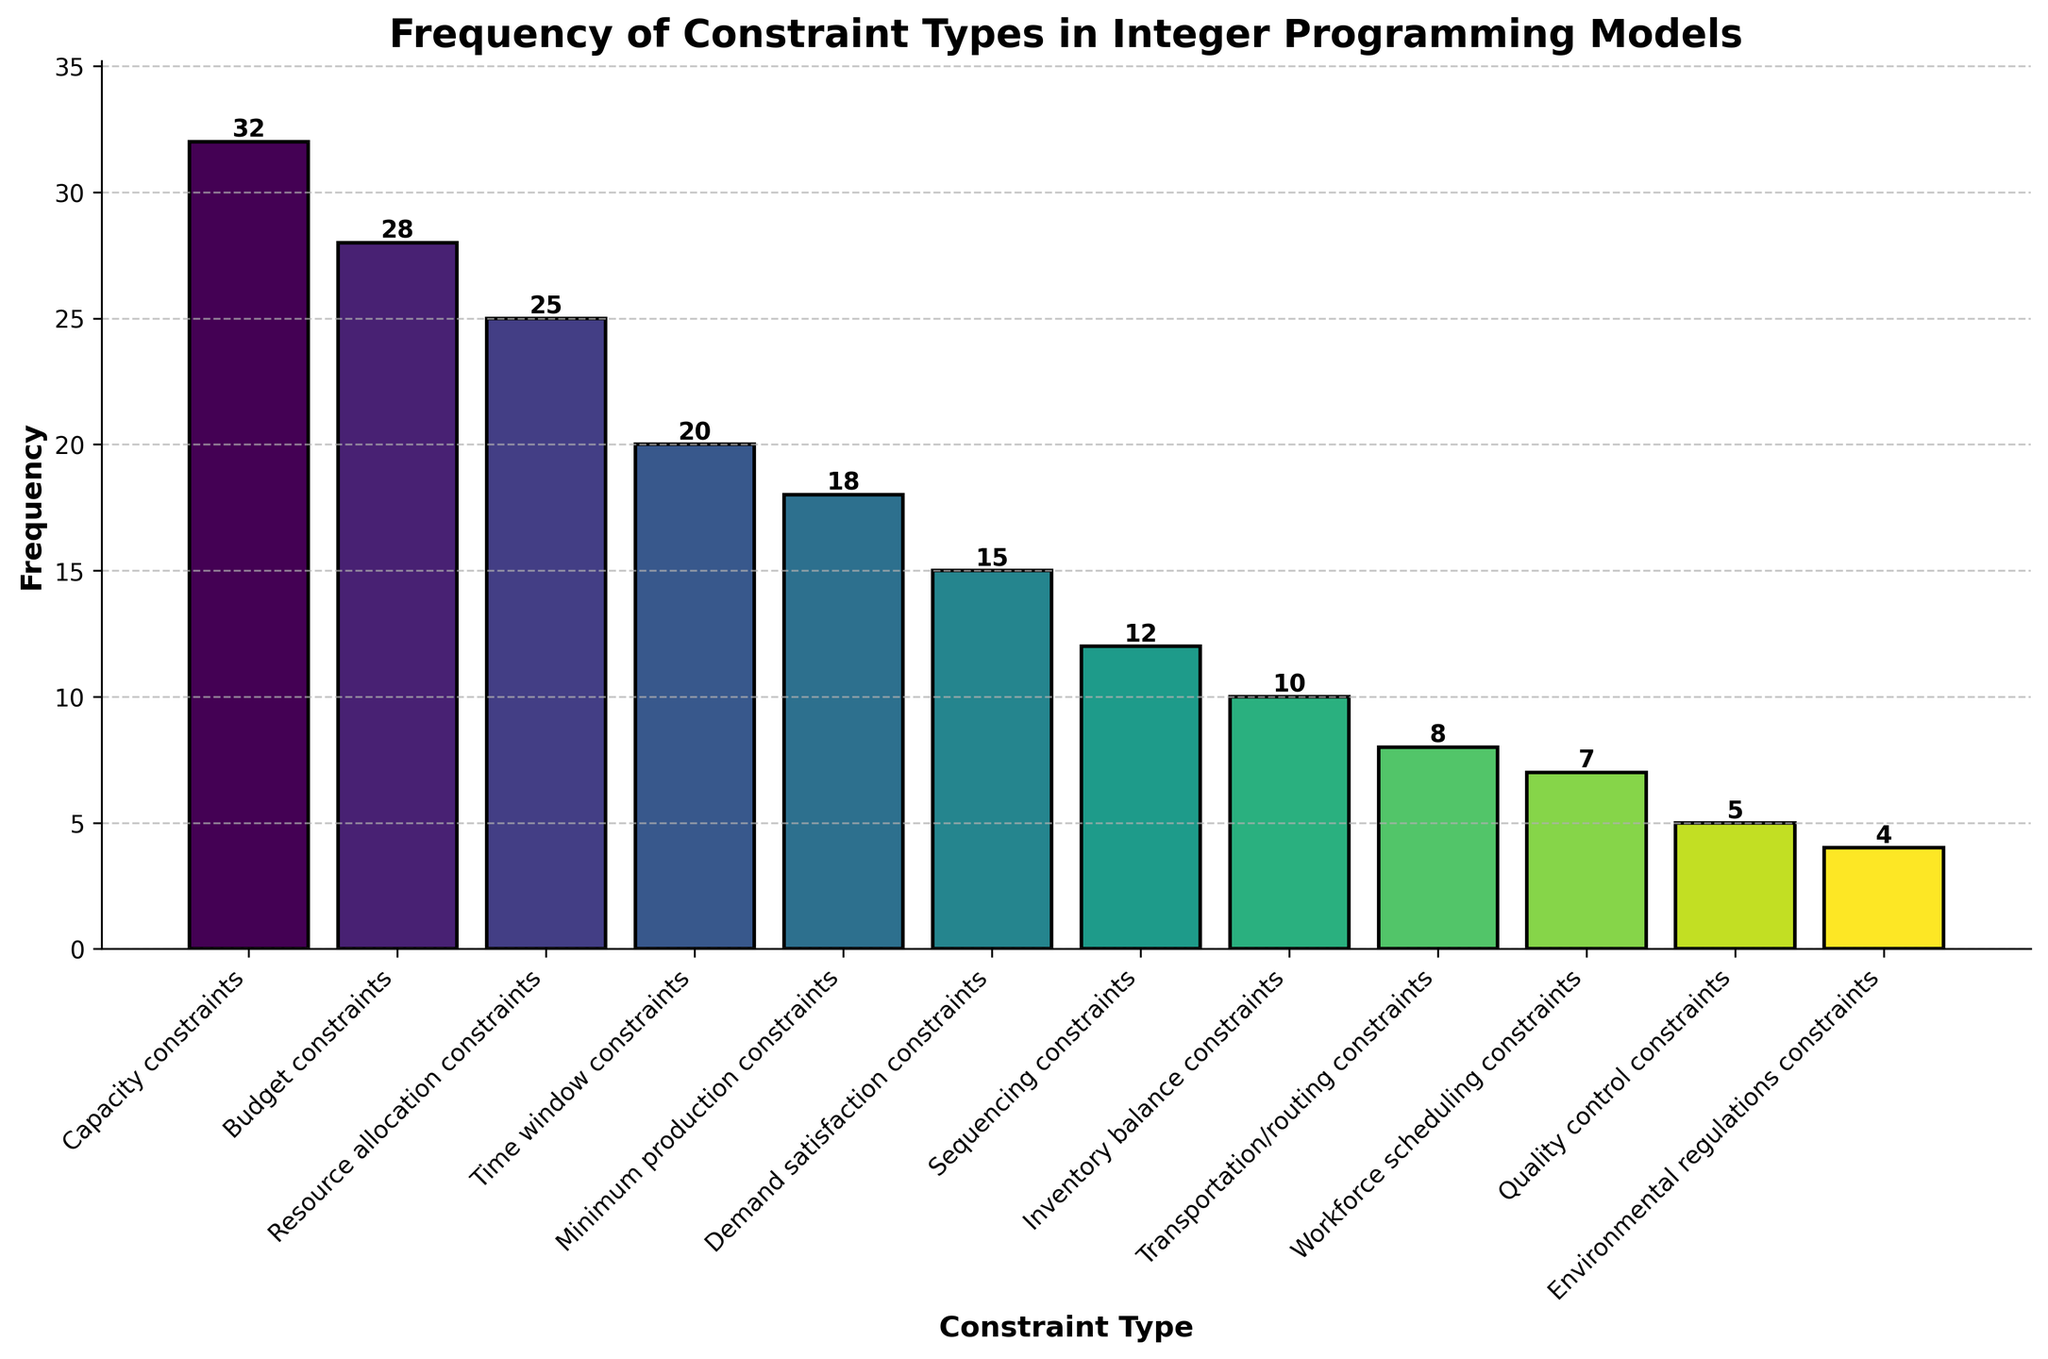What is the title of the figure? The title is typically located at the top of the figure and summarizes what the figure represents.
Answer: Frequency of Constraint Types in Integer Programming Models Which constraint type appears most frequently in the models? Examine the bars and identify the tallest one, which represents the highest frequency.
Answer: Capacity constraints How many types of constraints are depicted in the histogram? Count the number of different bars or categories along the x-axis.
Answer: 12 What is the frequency of "Budget constraints"? Locate the bar labeled "Budget constraints" and read the height, which corresponds to the frequency.
Answer: 28 How does the frequency of "Time window constraints" compare to "Minimum production constraints"? Compare the heights of the bars labeled "Time window constraints" and "Minimum production constraints" to see which is taller.
Answer: Time window constraints are more frequent than Minimum production constraints What is the combined frequency of "Resource allocation constraints" and "Demand satisfaction constraints"? Add the frequencies of the two constraint types: 25 (Resource allocation constraints) + 15 (Demand satisfaction constraints).
Answer: 40 What is the difference in frequency between the most common constraint type and the least common constraint type? Subtract the frequency of the least common type (4 for Environmental regulations constraints) from the most common type (32 for Capacity constraints).
Answer: 28 Which two constraint types have the closest frequencies? Compare the frequencies of all constraint types and identify the two with the smallest difference.
Answer: Minimum production constraints and Time window constraints Is the frequency of "Workforce scheduling constraints" greater than "Transportation/routing constraints"? Compare the heights of the bars labeled "Workforce scheduling constraints" (7) and "Transportation/routing constraints" (8).
Answer: No What is the average frequency of all constraint types represented in the histogram? Sum the frequencies of all constraint types and divide by the total number of constraint types (12). [(32+28+25+20+18+15+12+10+8+7+5+4)/12]
Answer: 15 What proportion of the total constraints does "Quality control constraints" represent? Divide the frequency of "Quality control constraints" (5) by the total sum of frequencies and convert to a percentage. [5/(32+28+25+20+18+15+12+10+8+7+5+4) * 100]
Answer: 3.9% 